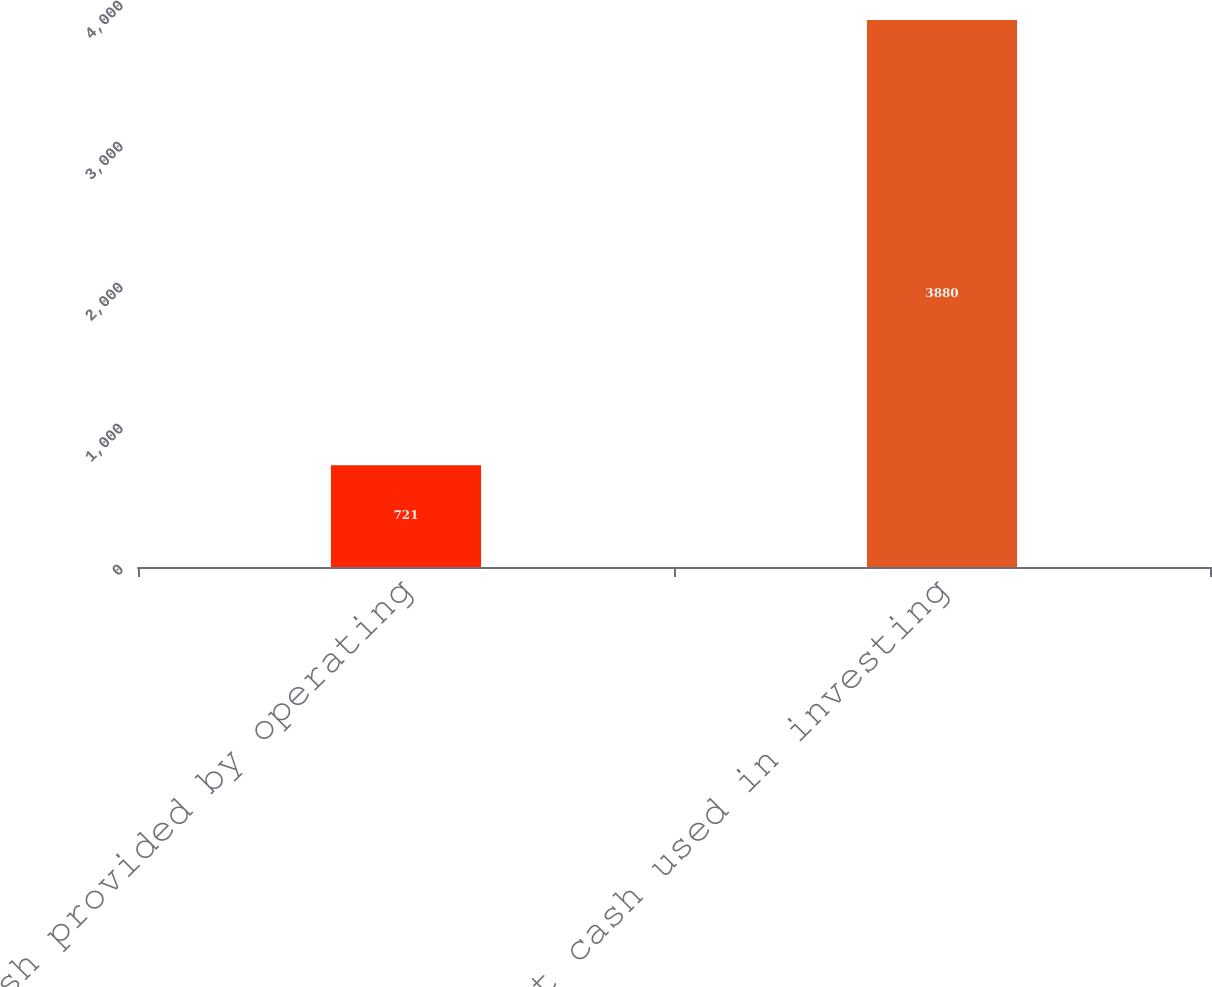<chart> <loc_0><loc_0><loc_500><loc_500><bar_chart><fcel>Net cash provided by operating<fcel>Net cash used in investing<nl><fcel>721<fcel>3880<nl></chart> 